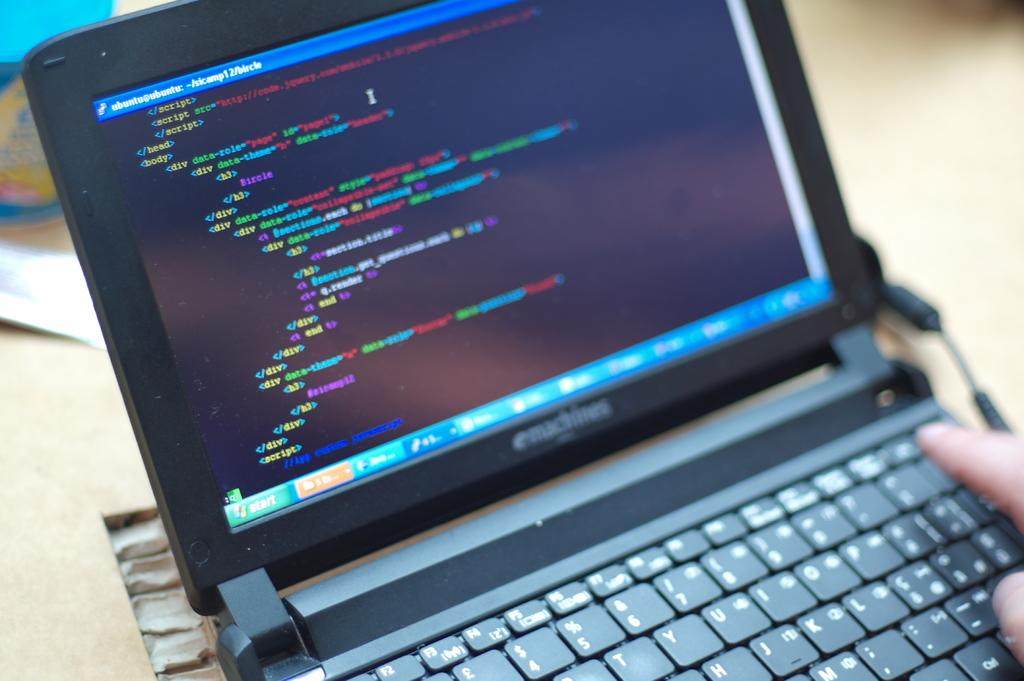What is the name of this application on the screen?
Offer a very short reply. Ubuntu. What word is on the green button on the bottom left corner of the screen?
Give a very brief answer. Start. 